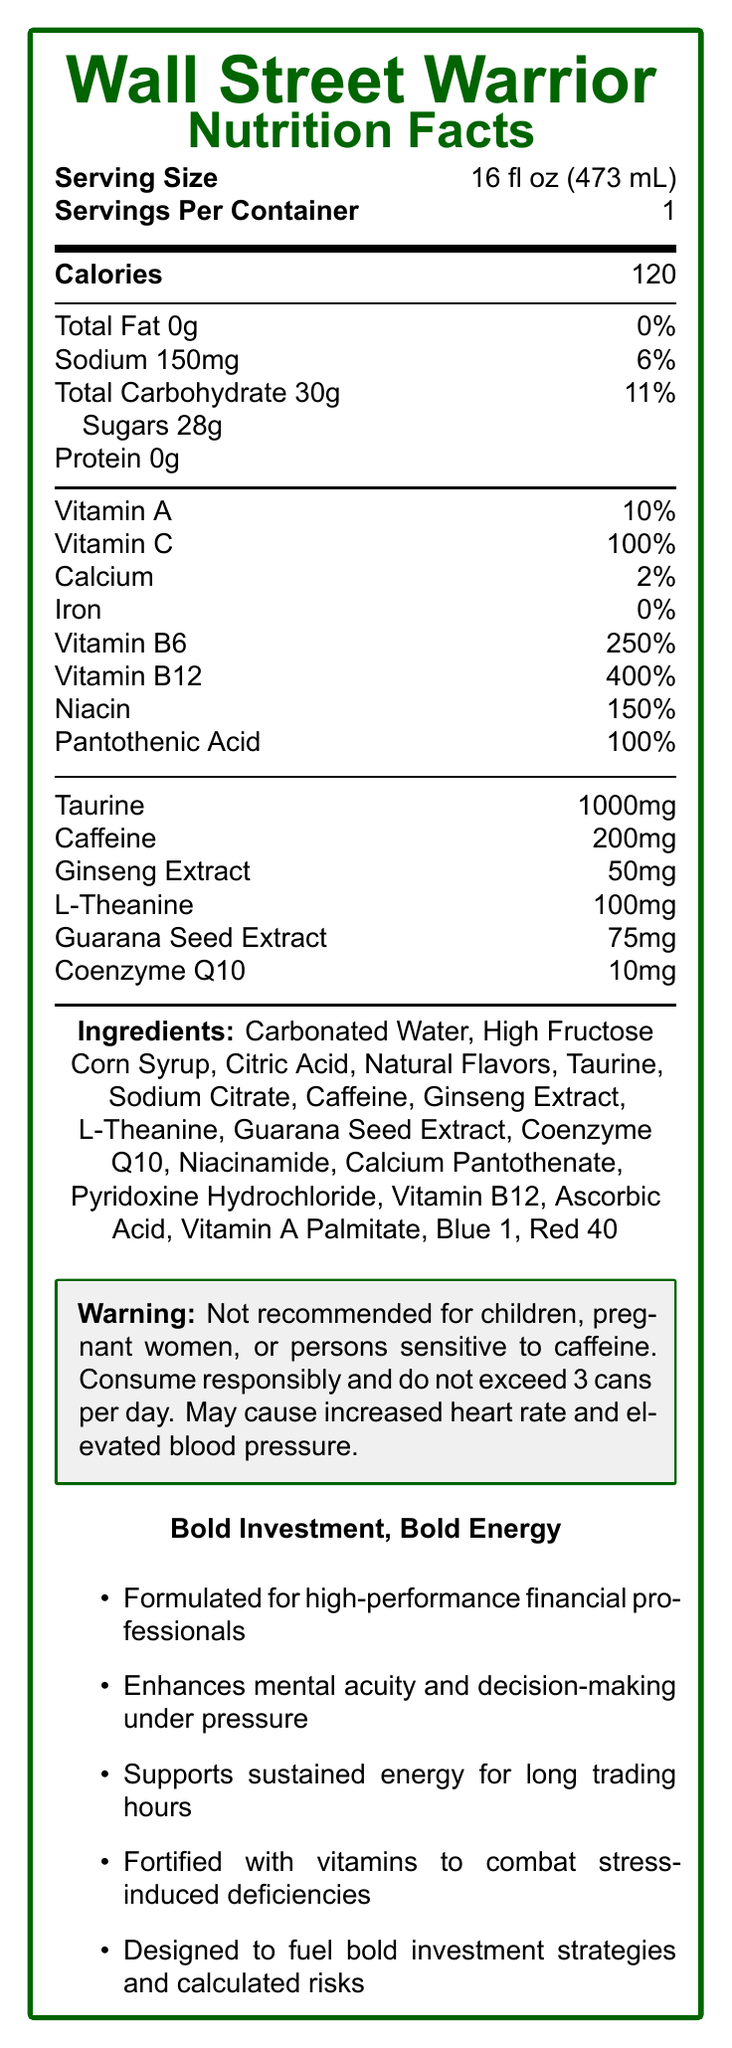what is the serving size of the Wall Street Warrior Energy Drink? The document lists the serving size directly as "16 fl oz (473 mL)."
Answer: 16 fl oz (473 mL) how many servings are there per container? The Nutrition Facts label explicitly states "Servings Per Container: 1."
Answer: 1 what is the total calorie content per serving? The label under "Calories" indicates that each serving contains 120 calories.
Answer: 120 how much caffeine is in one serving of the drink? The section listing additional ingredients includes "Caffeine 200mg."
Answer: 200mg what percentage of the daily value of vitamin C does this drink provide? The label specifies that the vitamin C content is 100% of the daily value.
Answer: 100% which of the following ingredients is NOT listed in the Wall Street Warrior Energy Drink? A. Sodium Citrate B. Ascorbic Acid C. Potassium Chloride D. L-Theanine The document lists Sodium Citrate, Ascorbic Acid, and L-Theanine, but does not mention Potassium Chloride.
Answer: C. Potassium Chloride how much sugar does one serving of this drink contain? A. 28g B. 15g C. 10g D. 5g The label under total carbohydrates specifies that sugars constitute 28g per serving.
Answer: A. 28g is this drink recommended for children and pregnant women? The warning box clearly states, "Not recommended for children, pregnant women, or persons sensitive to caffeine."
Answer: No summarize the main marketing claims of the Wall Street Warrior Energy Drink. The marketing claims emphasize the drink's benefits for mental acuity, energy support, vitamin fortification, and its suitability for high-stress financial decision-making environments.
Answer: The drink is formulated for high-performance financial professionals to enhance mental acuity, support sustained energy, combat stress-induced deficiencies, and fuel bold investment strategies. how much taurine is in the Wall Street Warrior Energy Drink? The label lists taurine content as 1000mg.
Answer: 1000mg which vitamin has the highest percentage of daily value in this drink? The label indicates that vitamin B12 is provided at 400% of the daily value, the highest among listed vitamins.
Answer: Vitamin B12 list the color additives used in Wall Street Warrior Energy Drink. The ingredient list includes "Blue 1" and "Red 40" as color additives.
Answer: Blue 1, Red 40 can this document tell me the exact origin of the ginseng extract? The document mentions "Ginseng Extract" but does not specify its origin.
Answer: Cannot be determined how much sodium does one serving of the Wall Street Warrior Energy Drink contain? The label lists "Sodium 150mg."
Answer: 150mg does this drink contain any protein? The label indicates "Protein 0g."
Answer: No what should you avoid doing when consuming this drink according to the disclaimers? The disclaimers specify that the drink should not be consumed by certain groups and should not be exceeded by more than 3 cans per day.
Answer: Avoid exceeding 3 cans per day and consumption by children, pregnant women, or persons sensitive to caffeine 